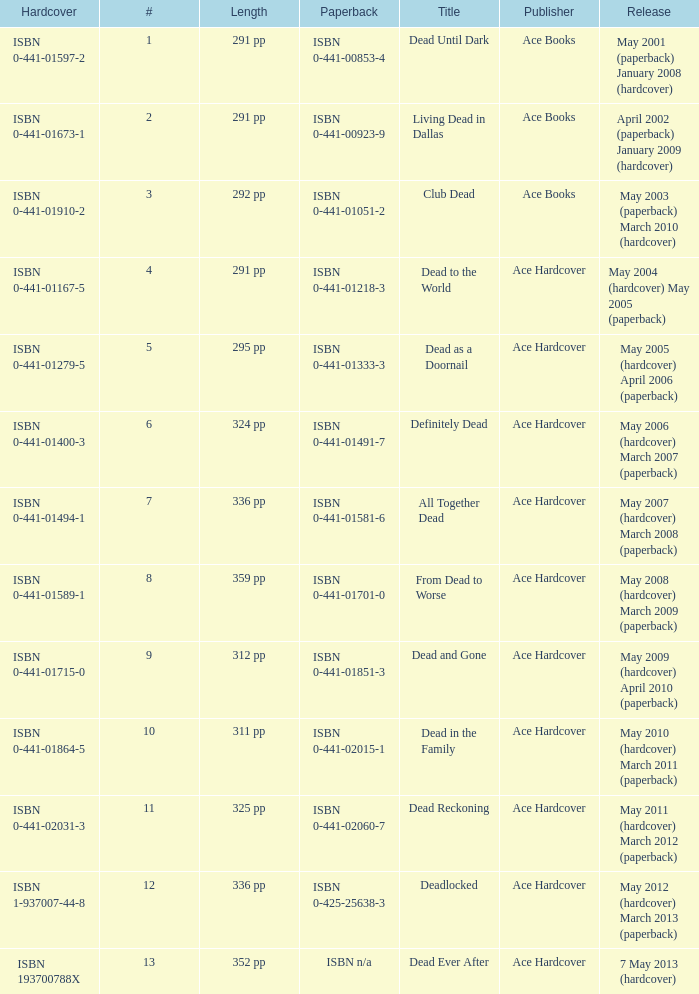Who pubilshed isbn 1-937007-44-8? Ace Hardcover. 